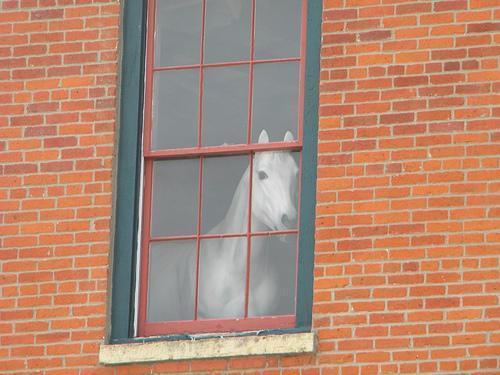How many panes are in the window?
Give a very brief answer. 12. 